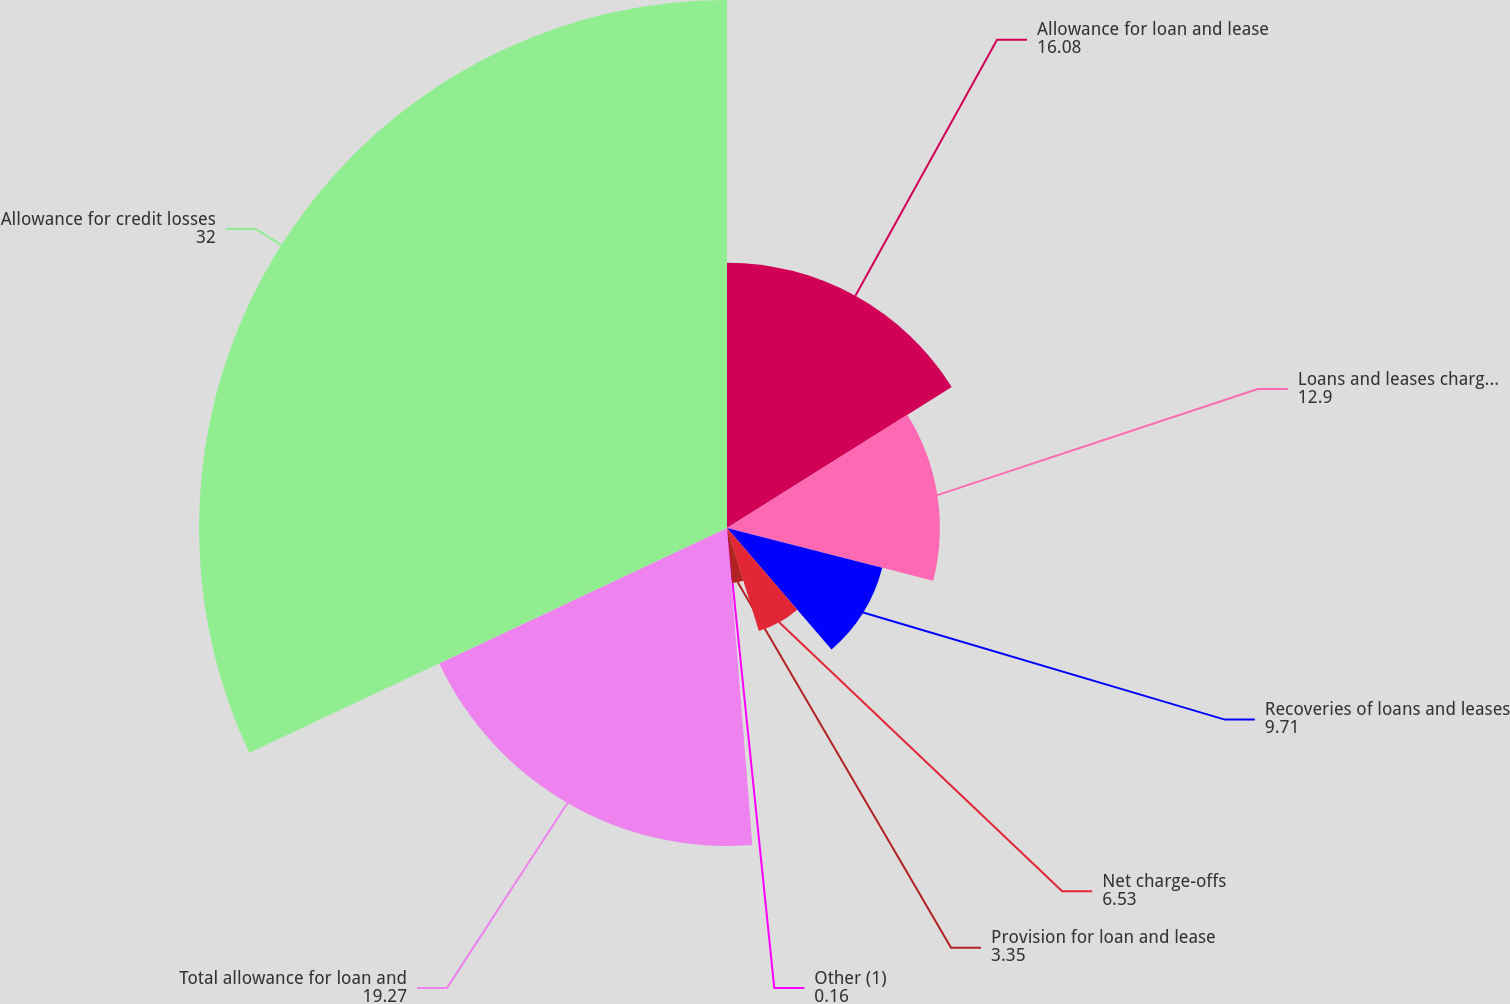Convert chart. <chart><loc_0><loc_0><loc_500><loc_500><pie_chart><fcel>Allowance for loan and lease<fcel>Loans and leases charged off<fcel>Recoveries of loans and leases<fcel>Net charge-offs<fcel>Provision for loan and lease<fcel>Other (1)<fcel>Total allowance for loan and<fcel>Allowance for credit losses<nl><fcel>16.08%<fcel>12.9%<fcel>9.71%<fcel>6.53%<fcel>3.35%<fcel>0.16%<fcel>19.27%<fcel>32.0%<nl></chart> 